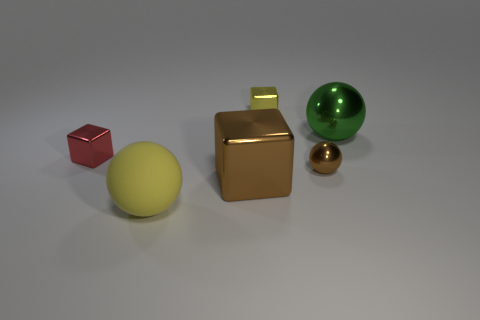Subtract all large cubes. How many cubes are left? 2 Add 3 red cubes. How many objects exist? 9 Subtract all red cubes. How many cubes are left? 2 Subtract 0 gray cylinders. How many objects are left? 6 Subtract 1 blocks. How many blocks are left? 2 Subtract all blue balls. Subtract all red cylinders. How many balls are left? 3 Subtract all small objects. Subtract all large green spheres. How many objects are left? 2 Add 3 green metallic things. How many green metallic things are left? 4 Add 1 tiny green matte things. How many tiny green matte things exist? 1 